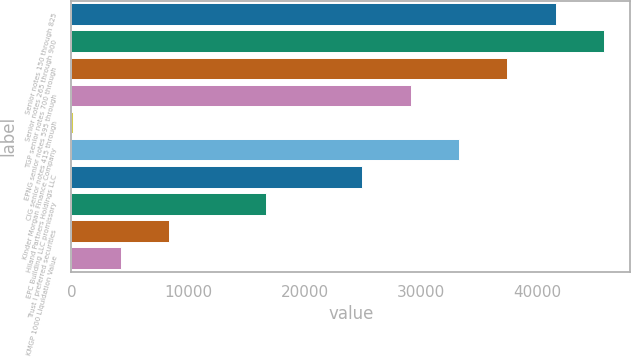<chart> <loc_0><loc_0><loc_500><loc_500><bar_chart><fcel>Senior notes 150 through 825<fcel>Senior notes 265 through 900<fcel>TGP senior notes 700 through<fcel>EPNG senior notes 595 through<fcel>CIG senior notes 415 through<fcel>Kinder Morgan Finance Company<fcel>Hiland Partners Holdings LLC<fcel>EPC Building LLC promissory<fcel>Trust I preferred securities<fcel>KMGP 1000 Liquidation Value<nl><fcel>41553<fcel>45698.3<fcel>37407.7<fcel>29117.1<fcel>100<fcel>33262.4<fcel>24971.8<fcel>16681.2<fcel>8390.6<fcel>4245.3<nl></chart> 